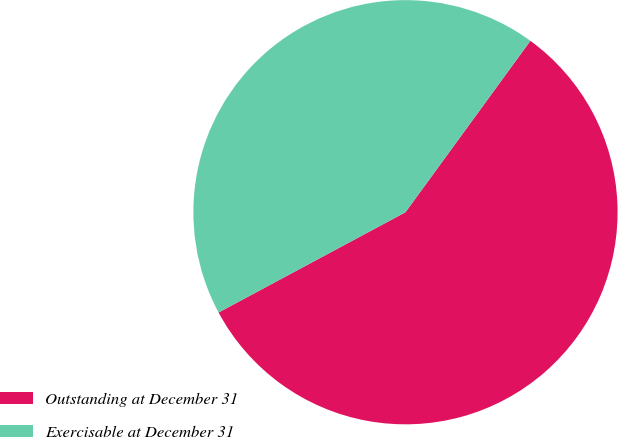<chart> <loc_0><loc_0><loc_500><loc_500><pie_chart><fcel>Outstanding at December 31<fcel>Exercisable at December 31<nl><fcel>57.14%<fcel>42.86%<nl></chart> 